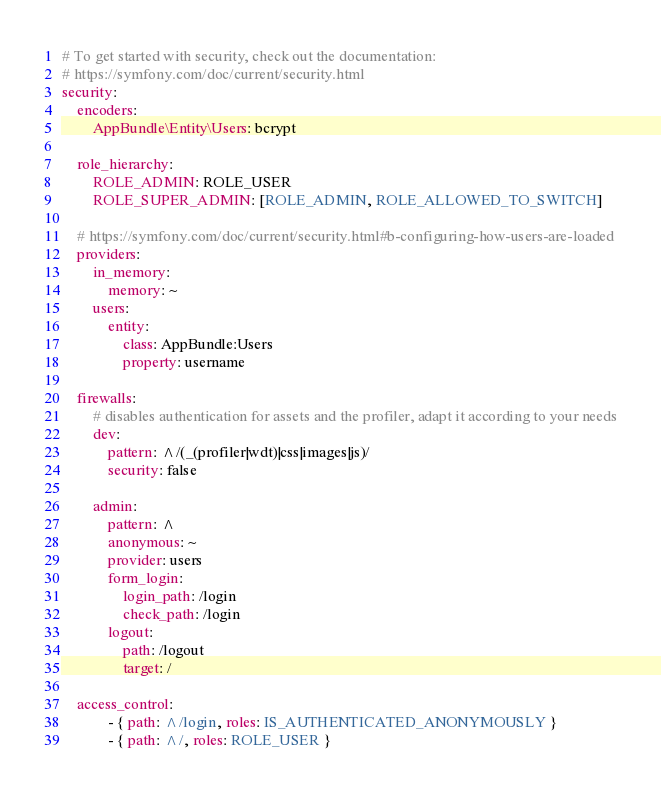<code> <loc_0><loc_0><loc_500><loc_500><_YAML_># To get started with security, check out the documentation:
# https://symfony.com/doc/current/security.html
security:
    encoders:
        AppBundle\Entity\Users: bcrypt

    role_hierarchy:
        ROLE_ADMIN: ROLE_USER
        ROLE_SUPER_ADMIN: [ROLE_ADMIN, ROLE_ALLOWED_TO_SWITCH]

    # https://symfony.com/doc/current/security.html#b-configuring-how-users-are-loaded
    providers:
        in_memory:
            memory: ~
        users:
            entity:
                class: AppBundle:Users
                property: username

    firewalls:
        # disables authentication for assets and the profiler, adapt it according to your needs
        dev:
            pattern: ^/(_(profiler|wdt)|css|images|js)/
            security: false

        admin:
            pattern: ^
            anonymous: ~
            provider: users
            form_login:
                login_path: /login
                check_path: /login
            logout:
                path: /logout
                target: /

    access_control:
            - { path: ^/login, roles: IS_AUTHENTICATED_ANONYMOUSLY }
            - { path: ^/, roles: ROLE_USER }
</code> 